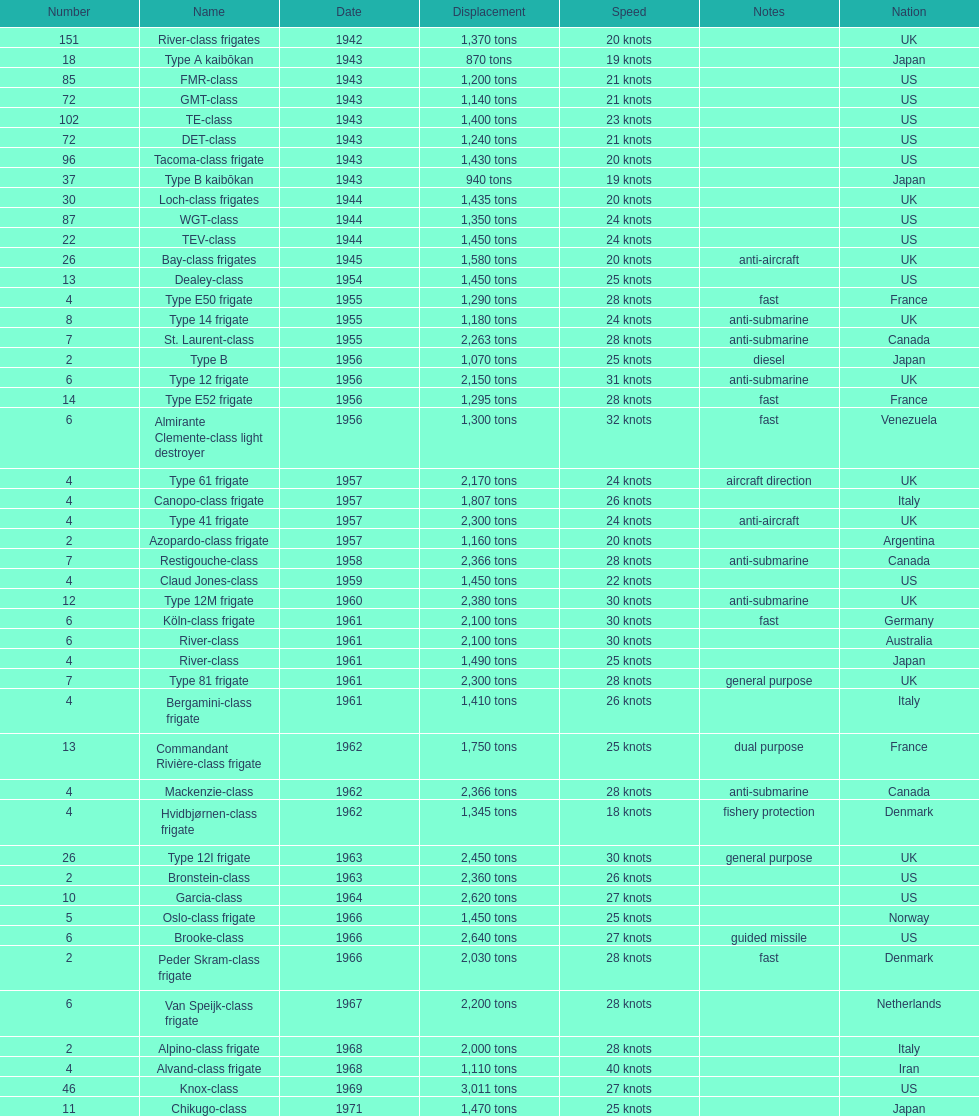How many consecutive escorts were in 1943? 7. Give me the full table as a dictionary. {'header': ['Number', 'Name', 'Date', 'Displacement', 'Speed', 'Notes', 'Nation'], 'rows': [['151', 'River-class frigates', '1942', '1,370 tons', '20 knots', '', 'UK'], ['18', 'Type A kaibōkan', '1943', '870 tons', '19 knots', '', 'Japan'], ['85', 'FMR-class', '1943', '1,200 tons', '21 knots', '', 'US'], ['72', 'GMT-class', '1943', '1,140 tons', '21 knots', '', 'US'], ['102', 'TE-class', '1943', '1,400 tons', '23 knots', '', 'US'], ['72', 'DET-class', '1943', '1,240 tons', '21 knots', '', 'US'], ['96', 'Tacoma-class frigate', '1943', '1,430 tons', '20 knots', '', 'US'], ['37', 'Type B kaibōkan', '1943', '940 tons', '19 knots', '', 'Japan'], ['30', 'Loch-class frigates', '1944', '1,435 tons', '20 knots', '', 'UK'], ['87', 'WGT-class', '1944', '1,350 tons', '24 knots', '', 'US'], ['22', 'TEV-class', '1944', '1,450 tons', '24 knots', '', 'US'], ['26', 'Bay-class frigates', '1945', '1,580 tons', '20 knots', 'anti-aircraft', 'UK'], ['13', 'Dealey-class', '1954', '1,450 tons', '25 knots', '', 'US'], ['4', 'Type E50 frigate', '1955', '1,290 tons', '28 knots', 'fast', 'France'], ['8', 'Type 14 frigate', '1955', '1,180 tons', '24 knots', 'anti-submarine', 'UK'], ['7', 'St. Laurent-class', '1955', '2,263 tons', '28 knots', 'anti-submarine', 'Canada'], ['2', 'Type B', '1956', '1,070 tons', '25 knots', 'diesel', 'Japan'], ['6', 'Type 12 frigate', '1956', '2,150 tons', '31 knots', 'anti-submarine', 'UK'], ['14', 'Type E52 frigate', '1956', '1,295 tons', '28 knots', 'fast', 'France'], ['6', 'Almirante Clemente-class light destroyer', '1956', '1,300 tons', '32 knots', 'fast', 'Venezuela'], ['4', 'Type 61 frigate', '1957', '2,170 tons', '24 knots', 'aircraft direction', 'UK'], ['4', 'Canopo-class frigate', '1957', '1,807 tons', '26 knots', '', 'Italy'], ['4', 'Type 41 frigate', '1957', '2,300 tons', '24 knots', 'anti-aircraft', 'UK'], ['2', 'Azopardo-class frigate', '1957', '1,160 tons', '20 knots', '', 'Argentina'], ['7', 'Restigouche-class', '1958', '2,366 tons', '28 knots', 'anti-submarine', 'Canada'], ['4', 'Claud Jones-class', '1959', '1,450 tons', '22 knots', '', 'US'], ['12', 'Type 12M frigate', '1960', '2,380 tons', '30 knots', 'anti-submarine', 'UK'], ['6', 'Köln-class frigate', '1961', '2,100 tons', '30 knots', 'fast', 'Germany'], ['6', 'River-class', '1961', '2,100 tons', '30 knots', '', 'Australia'], ['4', 'River-class', '1961', '1,490 tons', '25 knots', '', 'Japan'], ['7', 'Type 81 frigate', '1961', '2,300 tons', '28 knots', 'general purpose', 'UK'], ['4', 'Bergamini-class frigate', '1961', '1,410 tons', '26 knots', '', 'Italy'], ['13', 'Commandant Rivière-class frigate', '1962', '1,750 tons', '25 knots', 'dual purpose', 'France'], ['4', 'Mackenzie-class', '1962', '2,366 tons', '28 knots', 'anti-submarine', 'Canada'], ['4', 'Hvidbjørnen-class frigate', '1962', '1,345 tons', '18 knots', 'fishery protection', 'Denmark'], ['26', 'Type 12I frigate', '1963', '2,450 tons', '30 knots', 'general purpose', 'UK'], ['2', 'Bronstein-class', '1963', '2,360 tons', '26 knots', '', 'US'], ['10', 'Garcia-class', '1964', '2,620 tons', '27 knots', '', 'US'], ['5', 'Oslo-class frigate', '1966', '1,450 tons', '25 knots', '', 'Norway'], ['6', 'Brooke-class', '1966', '2,640 tons', '27 knots', 'guided missile', 'US'], ['2', 'Peder Skram-class frigate', '1966', '2,030 tons', '28 knots', 'fast', 'Denmark'], ['6', 'Van Speijk-class frigate', '1967', '2,200 tons', '28 knots', '', 'Netherlands'], ['2', 'Alpino-class frigate', '1968', '2,000 tons', '28 knots', '', 'Italy'], ['4', 'Alvand-class frigate', '1968', '1,110 tons', '40 knots', '', 'Iran'], ['46', 'Knox-class', '1969', '3,011 tons', '27 knots', '', 'US'], ['11', 'Chikugo-class', '1971', '1,470 tons', '25 knots', '', 'Japan']]} 